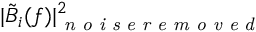Convert formula to latex. <formula><loc_0><loc_0><loc_500><loc_500>| \tilde { B } _ { i } ( f ) | _ { n o i s e r e m o v e d } ^ { 2 }</formula> 